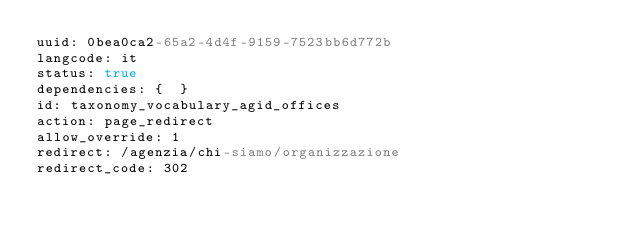<code> <loc_0><loc_0><loc_500><loc_500><_YAML_>uuid: 0bea0ca2-65a2-4d4f-9159-7523bb6d772b
langcode: it
status: true
dependencies: {  }
id: taxonomy_vocabulary_agid_offices
action: page_redirect
allow_override: 1
redirect: /agenzia/chi-siamo/organizzazione
redirect_code: 302
</code> 